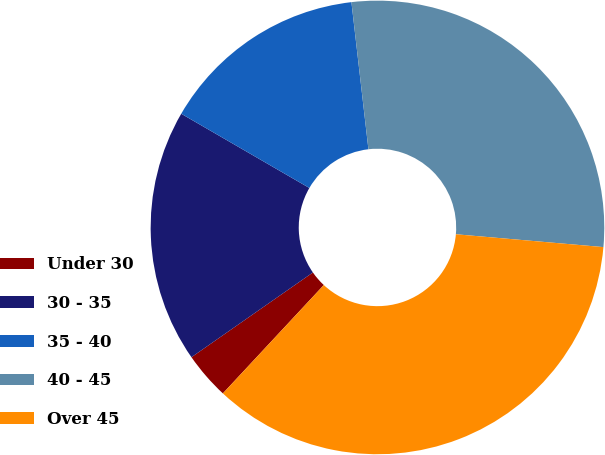Convert chart to OTSL. <chart><loc_0><loc_0><loc_500><loc_500><pie_chart><fcel>Under 30<fcel>30 - 35<fcel>35 - 40<fcel>40 - 45<fcel>Over 45<nl><fcel>3.37%<fcel>18.05%<fcel>14.81%<fcel>28.21%<fcel>35.55%<nl></chart> 